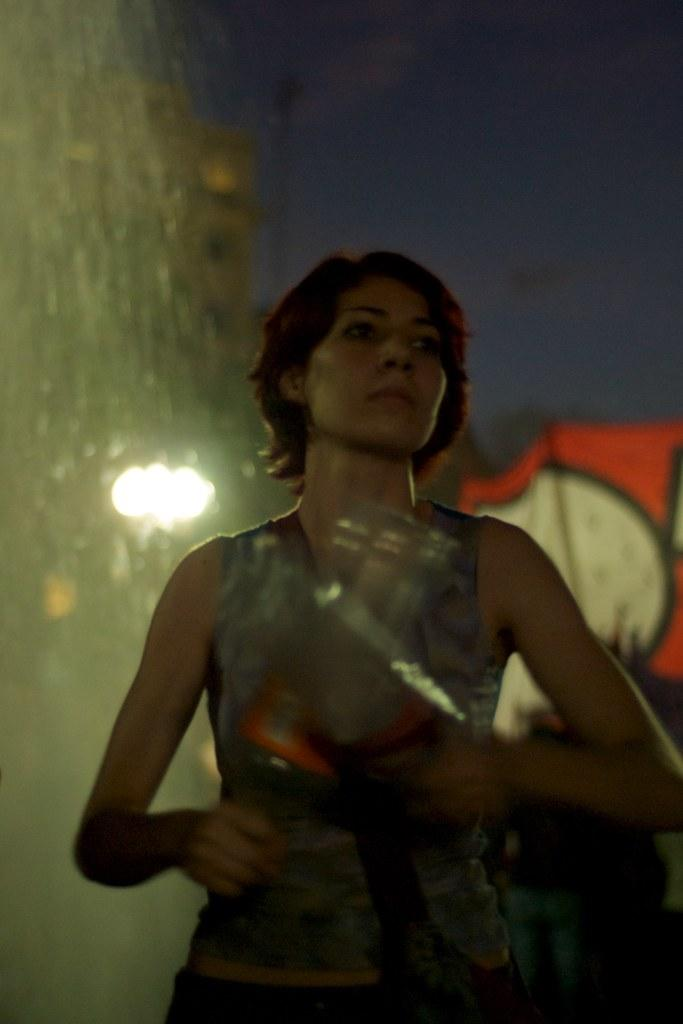What is the main subject of the image? There is a woman in the image. What is the woman doing in the image? The woman is standing in the image. What is the woman holding in the image? The woman is holding an object in the image. What can be seen in the background of the image? There is a wall and light in the background of the image. What type of sound can be heard coming from the iron in the image? There is no iron present in the image, so it is not possible to determine what, if any, sound might be heard. 